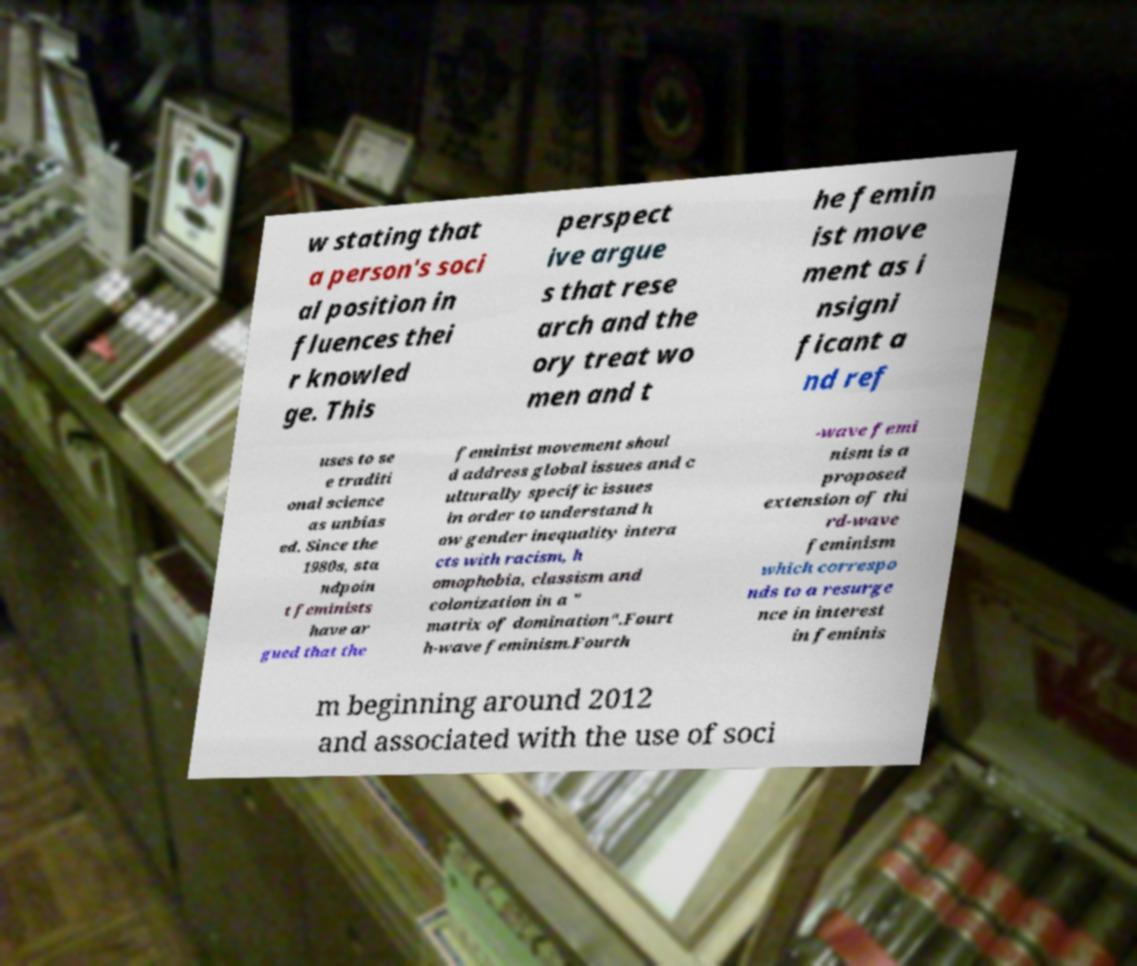I need the written content from this picture converted into text. Can you do that? w stating that a person's soci al position in fluences thei r knowled ge. This perspect ive argue s that rese arch and the ory treat wo men and t he femin ist move ment as i nsigni ficant a nd ref uses to se e traditi onal science as unbias ed. Since the 1980s, sta ndpoin t feminists have ar gued that the feminist movement shoul d address global issues and c ulturally specific issues in order to understand h ow gender inequality intera cts with racism, h omophobia, classism and colonization in a " matrix of domination".Fourt h-wave feminism.Fourth -wave femi nism is a proposed extension of thi rd-wave feminism which correspo nds to a resurge nce in interest in feminis m beginning around 2012 and associated with the use of soci 